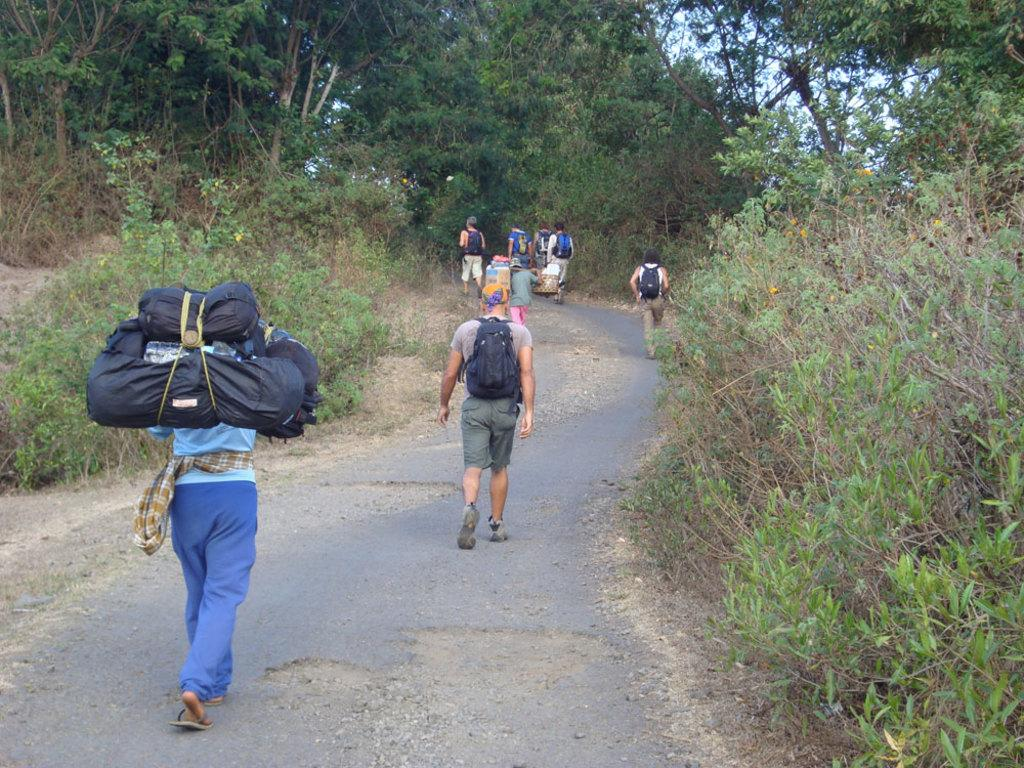What type of natural elements can be seen in the image? There are trees and plants in the image. What are the people in the image wearing? The people in the image are wearing bags. Where are the people located in the image? The people are in the middle of the image. What is at the bottom of the image? There is a road at the bottom of the image. What type of owl can be seen sitting on the appliance in the image? There is no owl or appliance present in the image. What store can be seen in the background of the image? There is no store visible in the image; it features trees, plants, people, and a road. 